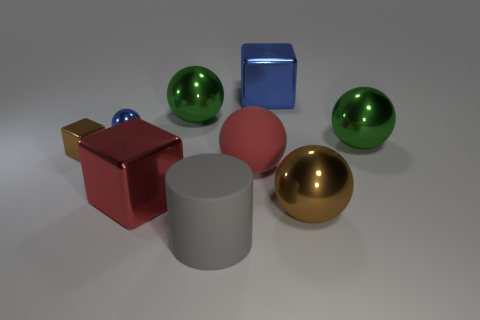How many big blue metallic objects are to the left of the big brown metal ball to the right of the brown metal object that is behind the brown sphere?
Ensure brevity in your answer.  1. There is a thing that is the same color as the rubber ball; what material is it?
Provide a short and direct response. Metal. What number of shiny objects are there?
Make the answer very short. 7. Does the blue shiny object that is on the right side of the matte sphere have the same size as the small blue shiny thing?
Your answer should be very brief. No. How many metallic things are big gray cylinders or large brown spheres?
Your answer should be very brief. 1. There is a tiny cube behind the large red matte sphere; how many large metallic cubes are on the left side of it?
Give a very brief answer. 0. The thing that is in front of the large red matte thing and to the left of the rubber cylinder has what shape?
Keep it short and to the point. Cube. What material is the tiny thing behind the small cube to the left of the big shiny sphere that is in front of the brown cube?
Keep it short and to the point. Metal. What is the material of the blue sphere?
Make the answer very short. Metal. Is the material of the gray object the same as the large red object that is on the right side of the large gray cylinder?
Offer a terse response. Yes. 